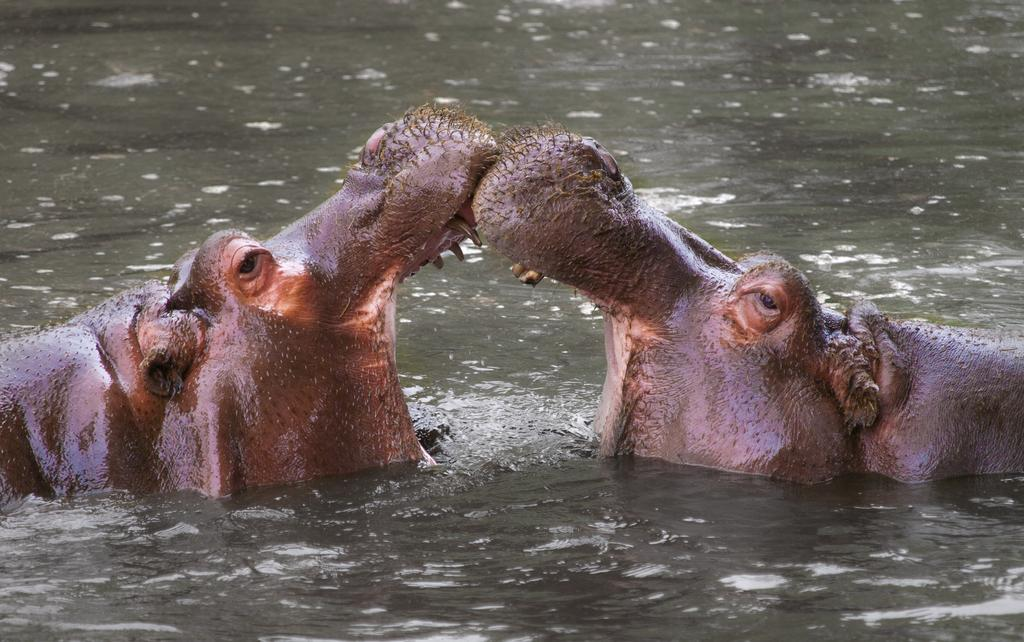What animals are present in the image? There are two hippopotamuses in the image. Where are the hippopotamuses located in the image? The hippopotamuses are in water and in the center of the image. What type of test can be seen being conducted on the hippopotamuses in the image? There is no test being conducted on the hippopotamuses in the image; they are simply in water. What type of creature is touching the hippopotamuses in the image? There is no creature touching the hippopotamuses in the image; they are in water without any other creatures present. 